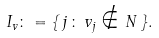Convert formula to latex. <formula><loc_0><loc_0><loc_500><loc_500>I _ { v } \colon = \{ \, j \, \colon \, v _ { j } \notin { N } \, \} .</formula> 